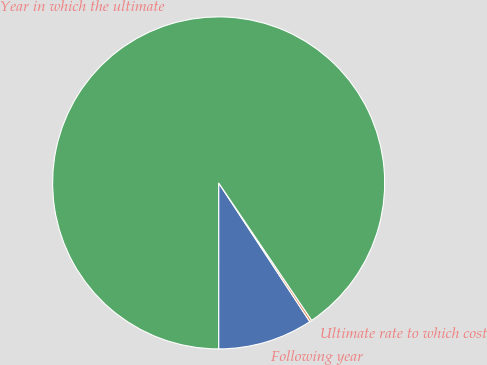Convert chart to OTSL. <chart><loc_0><loc_0><loc_500><loc_500><pie_chart><fcel>Following year<fcel>Ultimate rate to which cost<fcel>Year in which the ultimate<nl><fcel>9.25%<fcel>0.22%<fcel>90.52%<nl></chart> 